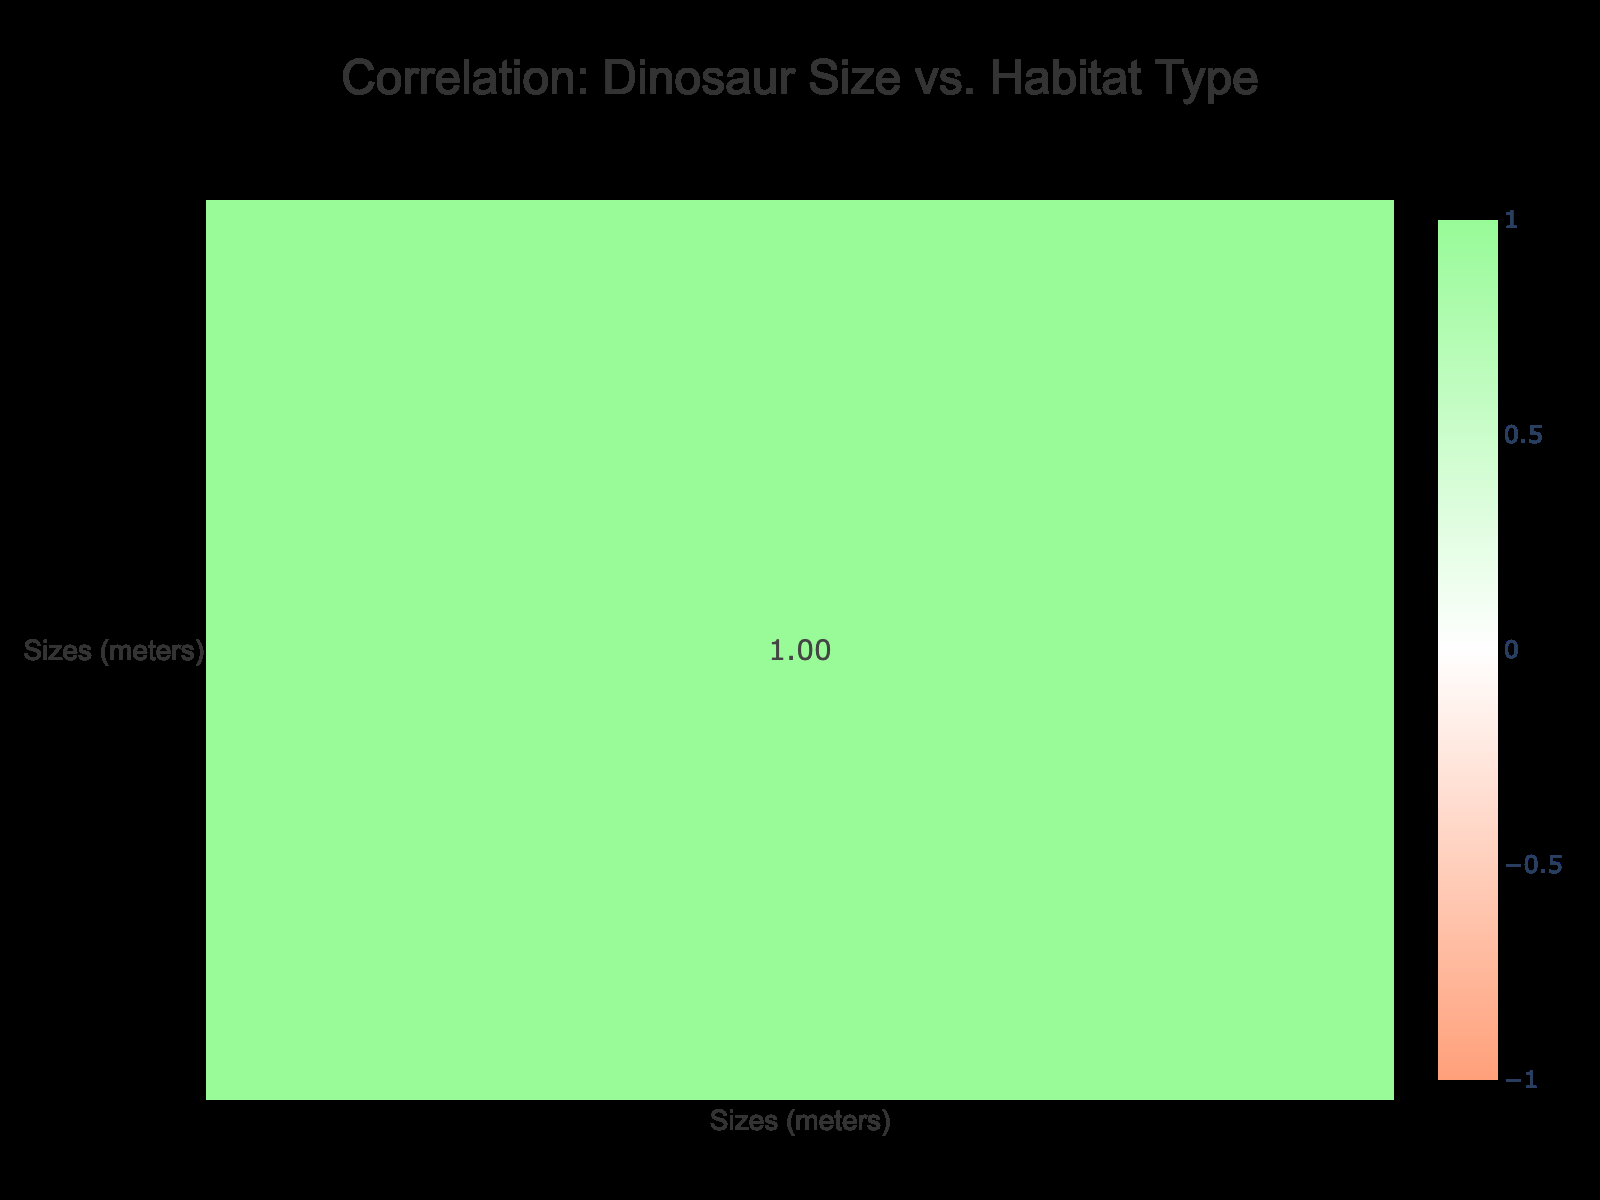What is the size of the Velociraptor? The Velociraptor is listed in the table with a size of 1.8 meters.
Answer: 1.8 meters Which dinosaur has the largest size? The Brachiosaurus has the largest size at 25.0 meters, according to the table.
Answer: 25.0 meters Are there any dinosaurs that inhabit the Desert habitat? Yes, the Velociraptor is the only dinosaur listed that inhabits the Desert habitat.
Answer: Yes What is the average size of the dinosaurs that live in Terrestrial habitats? The only dinosaur in the Terrestrial habitat is the Tyrannosaurus Rex, which is 12.3 meters in size. Since there is only one dinosaur, the average size is also 12.3 meters.
Answer: 12.3 meters Do any dinosaurs in the table inhabit both Forest and Forested Areas? No, there is no overlap; Brachiosaurus is in Forest, and Ankylosaurus is in Forested Areas.
Answer: No What is the difference in size between the largest and smallest dinosaurs? The largest dinosaur is the Brachiosaurus at 25.0 meters and the smallest is the Micropachycephalosaurus at 1.3 meters. To find the difference: 25.0 - 1.3 = 23.7 meters.
Answer: 23.7 meters Which habitat type has the smallest dinosaur? The Velociraptor, which is 1.8 meters, inhabits the Desert habitat, making it the smallest dinosaur in that category.
Answer: Desert How would you categorize the majority of the dinosaurs in terms of their habitat type? The habitats are: Terrestrial, Forest, Grassland, Plains, Desert, Forested Areas, Riverbanks, Caribbean Coastal, and Swamp. Among these, Terrestrial and Forest seem to be popular categories. However, there are different habitats present, indicating diversity.
Answer: Diverse habitats What is the correlation between dinosaur size and habitat type based on this table? The sizes of dinosaurs do not correlate strongly with specific habitat types, as size varies significantly without clustering by habitat. The correlation matrix might show a weak correlation.
Answer: Weak correlation 